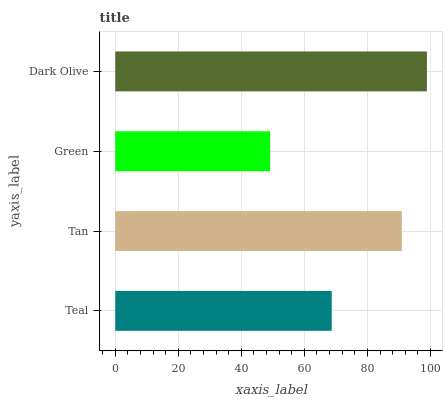Is Green the minimum?
Answer yes or no. Yes. Is Dark Olive the maximum?
Answer yes or no. Yes. Is Tan the minimum?
Answer yes or no. No. Is Tan the maximum?
Answer yes or no. No. Is Tan greater than Teal?
Answer yes or no. Yes. Is Teal less than Tan?
Answer yes or no. Yes. Is Teal greater than Tan?
Answer yes or no. No. Is Tan less than Teal?
Answer yes or no. No. Is Tan the high median?
Answer yes or no. Yes. Is Teal the low median?
Answer yes or no. Yes. Is Teal the high median?
Answer yes or no. No. Is Green the low median?
Answer yes or no. No. 